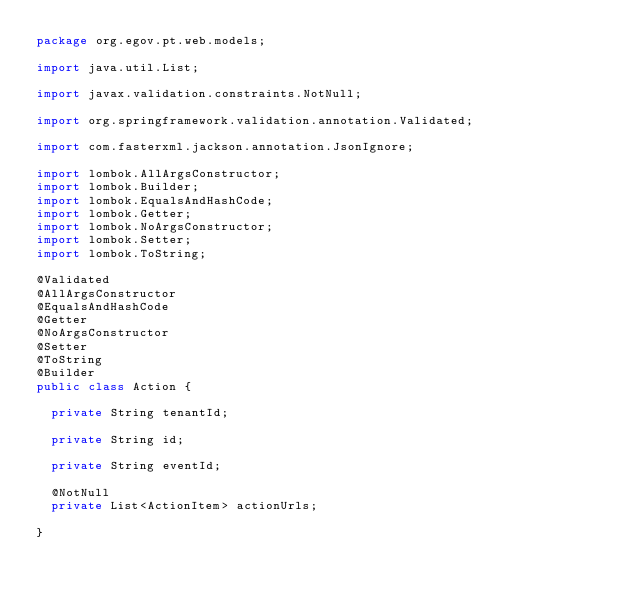<code> <loc_0><loc_0><loc_500><loc_500><_Java_>package org.egov.pt.web.models;

import java.util.List;

import javax.validation.constraints.NotNull;

import org.springframework.validation.annotation.Validated;

import com.fasterxml.jackson.annotation.JsonIgnore;

import lombok.AllArgsConstructor;
import lombok.Builder;
import lombok.EqualsAndHashCode;
import lombok.Getter;
import lombok.NoArgsConstructor;
import lombok.Setter;
import lombok.ToString;

@Validated
@AllArgsConstructor
@EqualsAndHashCode
@Getter
@NoArgsConstructor
@Setter
@ToString
@Builder
public class Action {
	
	private String tenantId;
	
	private String id;
	
	private String eventId;
	
	@NotNull
	private List<ActionItem> actionUrls;
	
}
</code> 